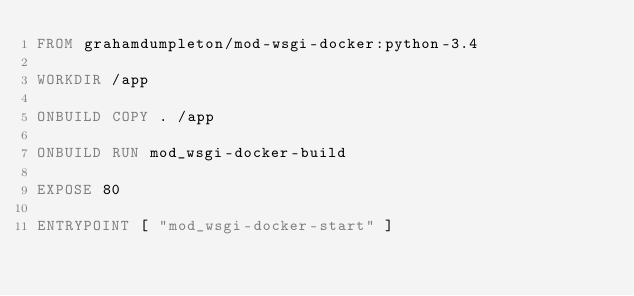<code> <loc_0><loc_0><loc_500><loc_500><_Dockerfile_>FROM grahamdumpleton/mod-wsgi-docker:python-3.4

WORKDIR /app

ONBUILD COPY . /app

ONBUILD RUN mod_wsgi-docker-build

EXPOSE 80

ENTRYPOINT [ "mod_wsgi-docker-start" ]
</code> 